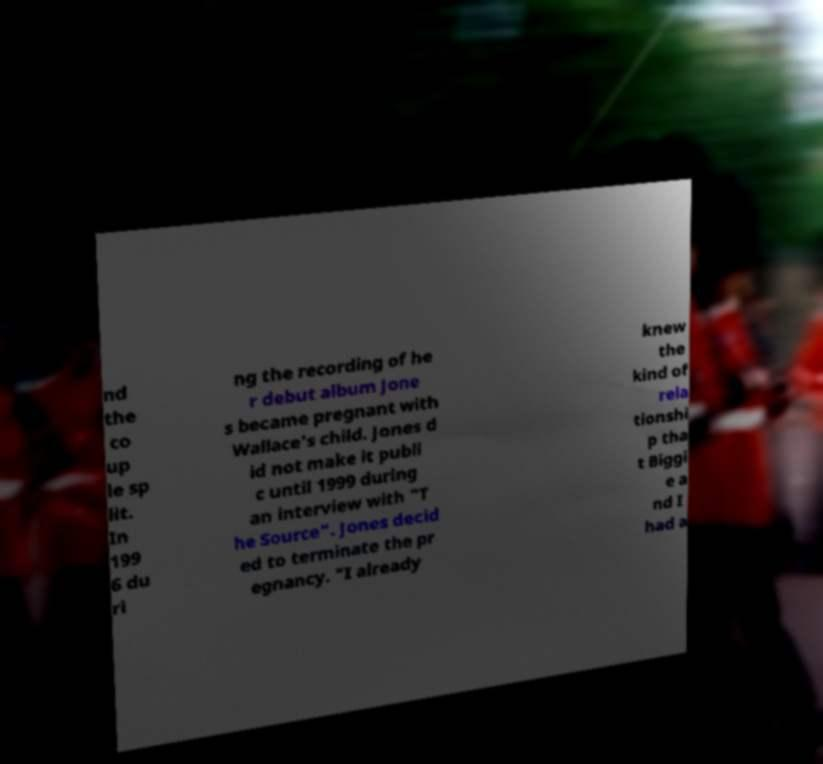Please read and relay the text visible in this image. What does it say? nd the co up le sp lit. In 199 6 du ri ng the recording of he r debut album Jone s became pregnant with Wallace's child. Jones d id not make it publi c until 1999 during an interview with "T he Source". Jones decid ed to terminate the pr egnancy. "I already knew the kind of rela tionshi p tha t Biggi e a nd I had a 